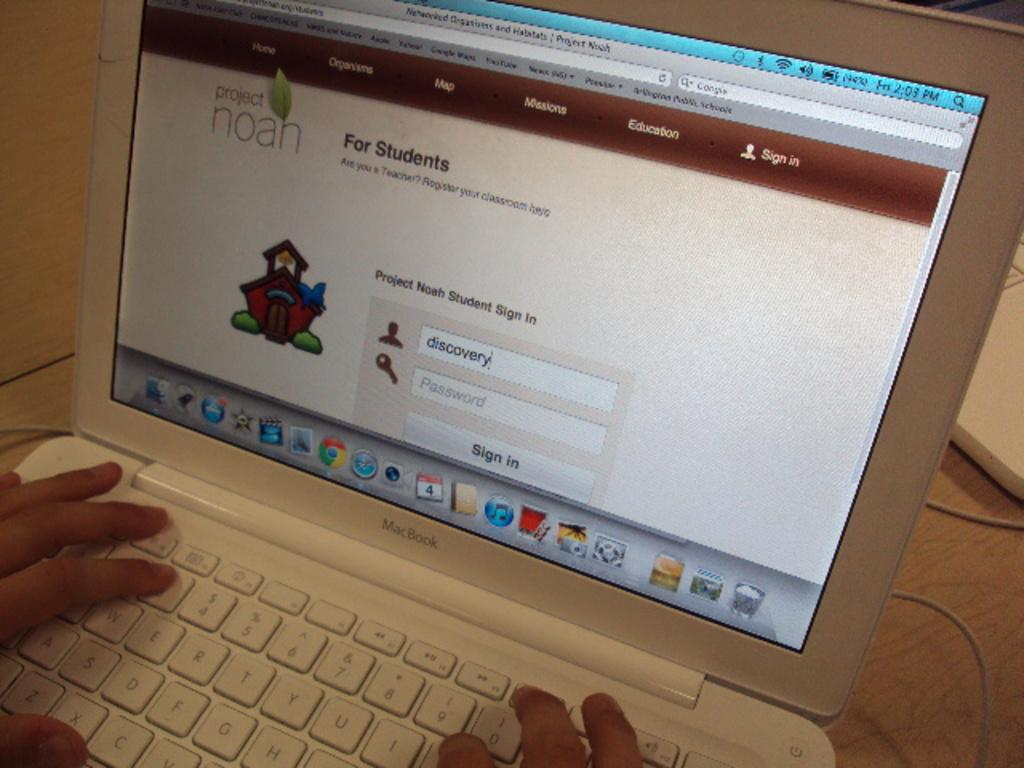Provide a one-sentence caption for the provided image. Person using a Macbook with a screen saying "For Students". 